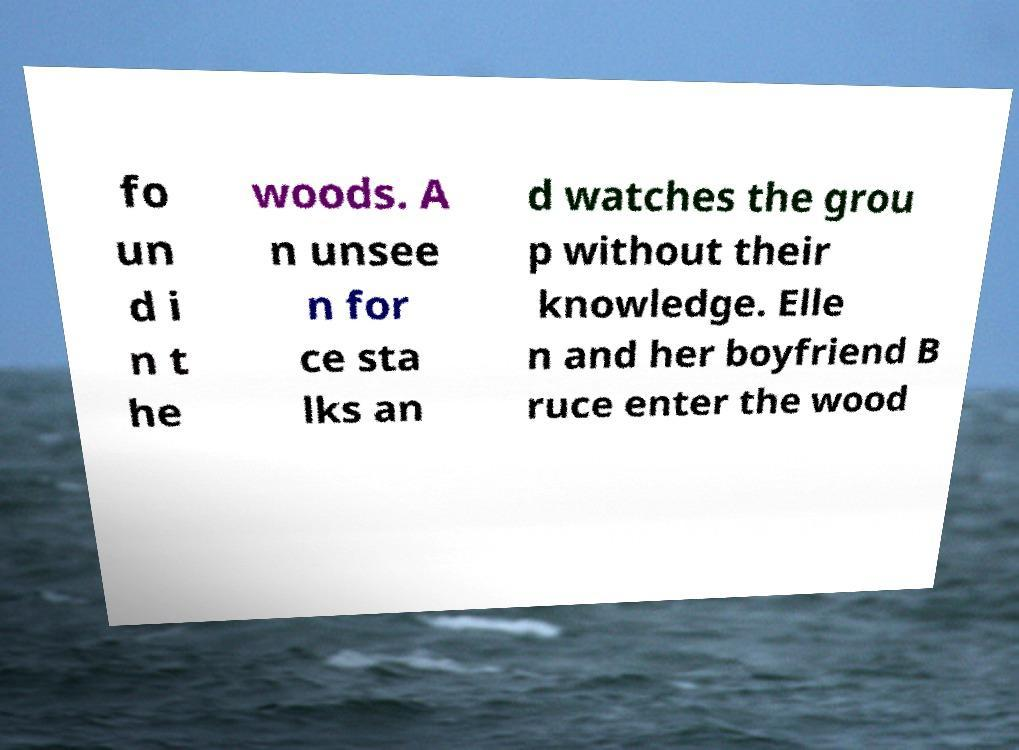I need the written content from this picture converted into text. Can you do that? fo un d i n t he woods. A n unsee n for ce sta lks an d watches the grou p without their knowledge. Elle n and her boyfriend B ruce enter the wood 